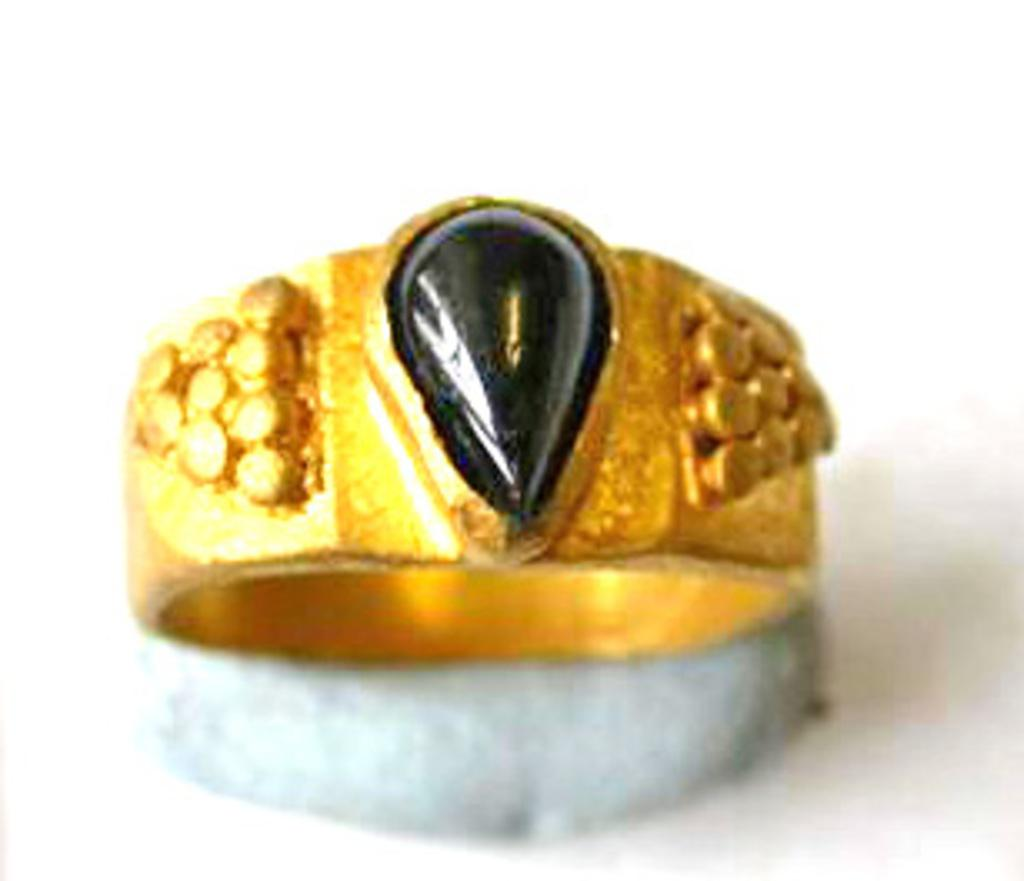What is the main object in the image? There is a ring in the image. How many cabbages are present in the image? There are no cabbages present in the image. Are there any spiders visible in the image? There is no mention of spiders in the image, so it cannot be determined if any are present. Can you see a dog in the image? There is no mention of a dog in the image, so it cannot be determined if one is present. 